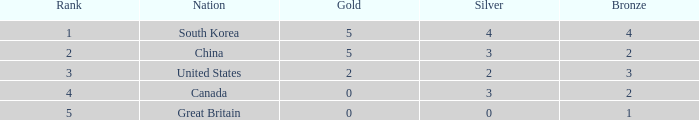What is the lowest Rank, when Nation is Great Britain, and when Bronze is less than 1? None. 